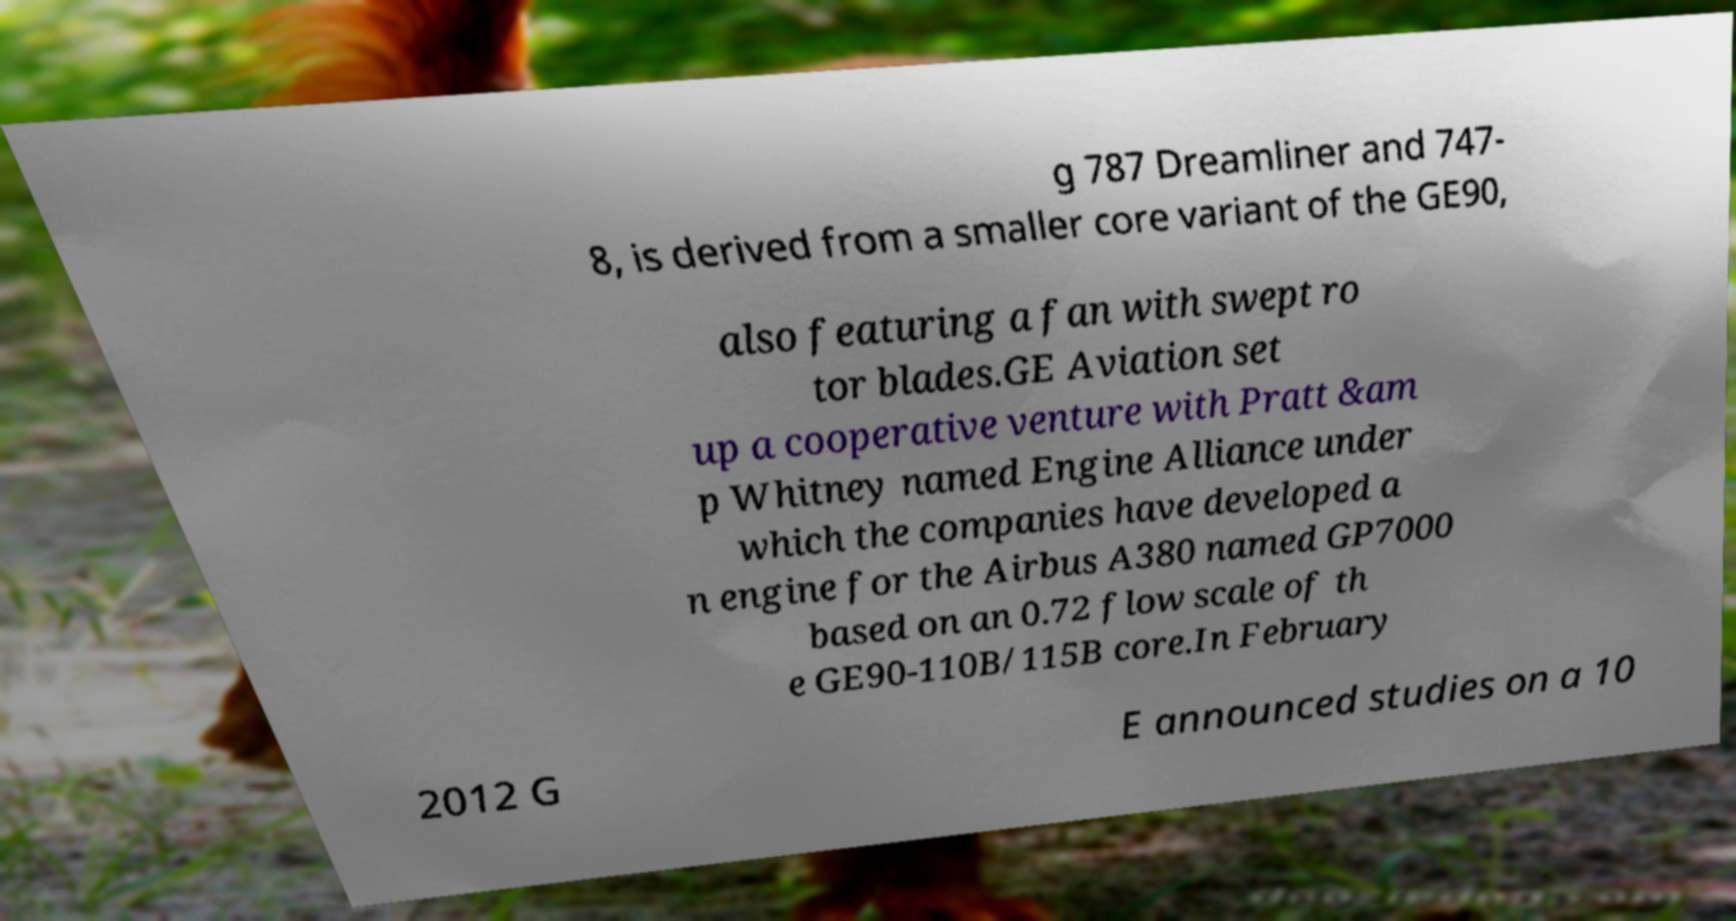Could you extract and type out the text from this image? g 787 Dreamliner and 747- 8, is derived from a smaller core variant of the GE90, also featuring a fan with swept ro tor blades.GE Aviation set up a cooperative venture with Pratt &am p Whitney named Engine Alliance under which the companies have developed a n engine for the Airbus A380 named GP7000 based on an 0.72 flow scale of th e GE90-110B/115B core.In February 2012 G E announced studies on a 10 